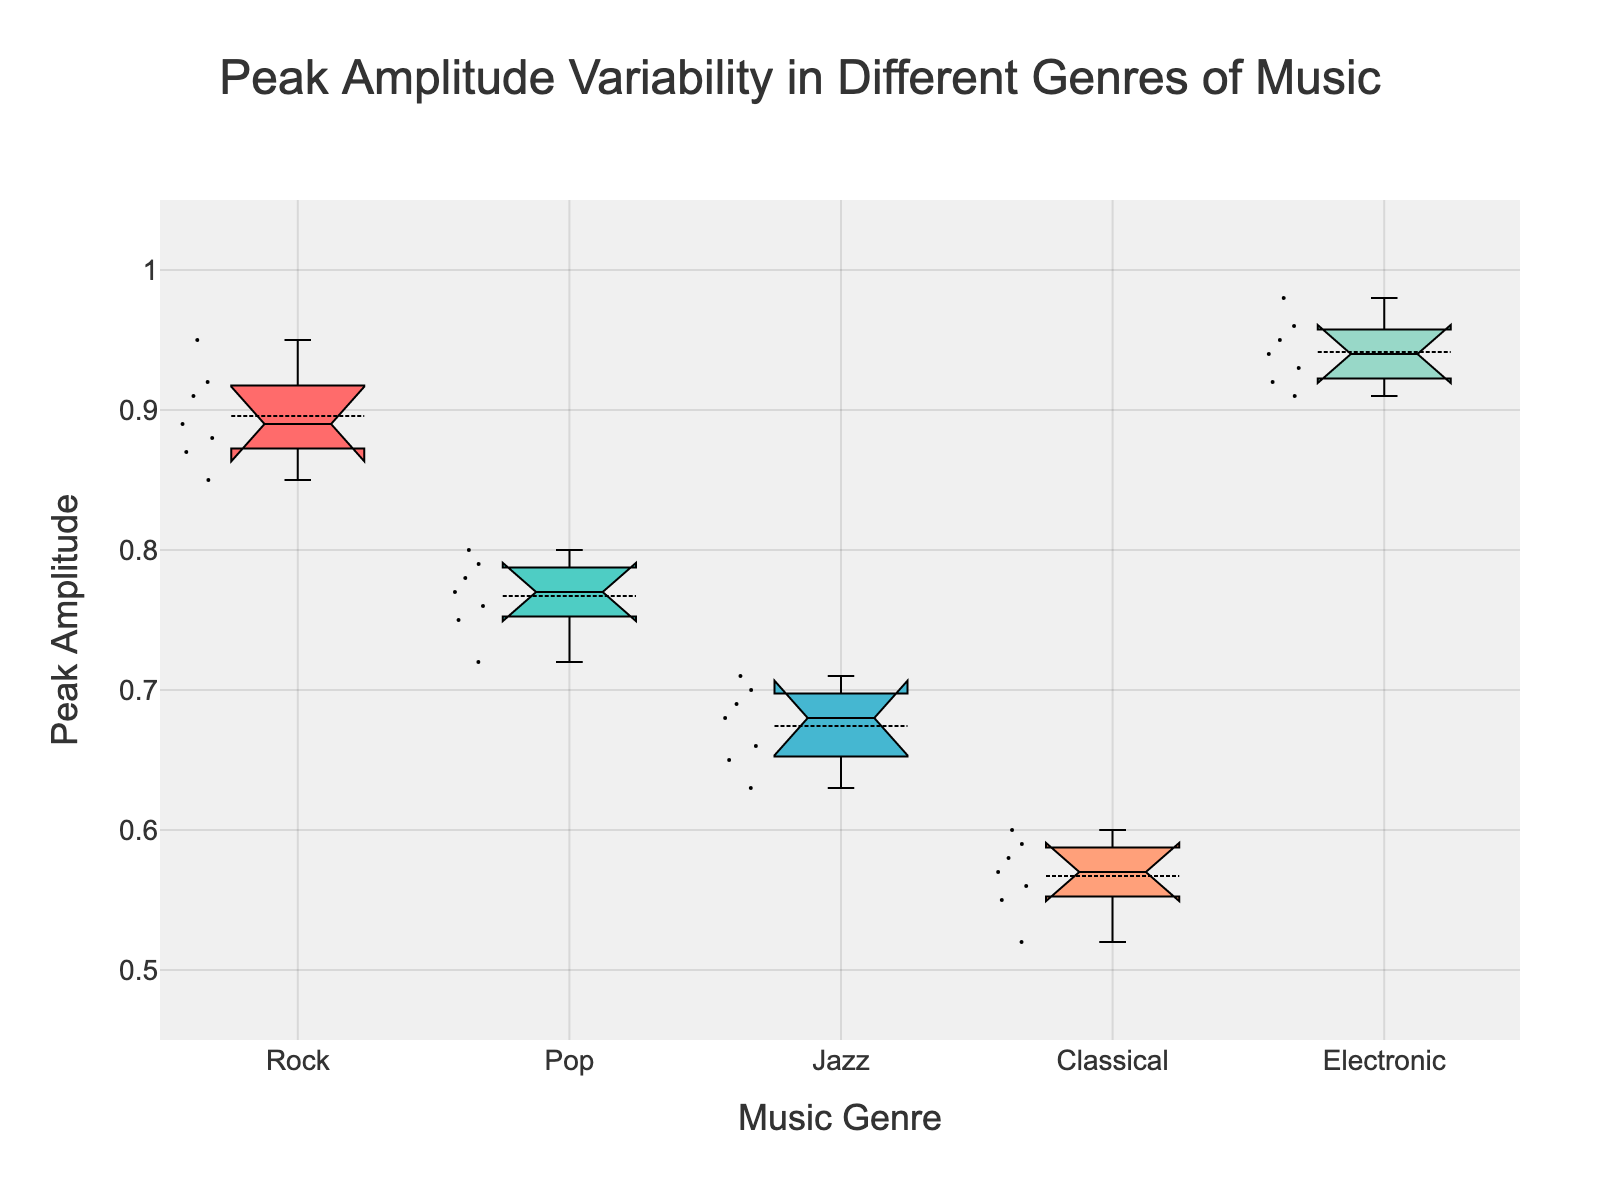What is the peak amplitude range for the Classical genre? The peak amplitude range for Classical can be determined by the lower and upper whiskers of the box plot for the Classical genre.
Answer: 0.52 to 0.60 Which genre has the highest median peak amplitude? The median peak amplitudes can be identified by the line inside each box. The genre with the highest median has the highest central line.
Answer: Electronic How does the median peak amplitude of Rock compare to Pop? By comparing the central lines of Rock and Pop boxes, we can see which one is higher.
Answer: Rock is higher than Pop Which genre shows the most variability in peak amplitude? Varied peak amplitude is shown by the length of the box and whiskers. The genre with the widest box and whiskers has the most variability.
Answer: Electronic Is the median peak amplitude of Jazz closer to Rock or Pop? By comparing the median lines of Jazz with those of Rock and Pop, we can determine which one is closer to Jazz.
Answer: Pop What is the interquartile range (IQR) for Pop? The IQR can be found by subtracting the lower quartile (bottom of the box) from the upper quartile (top of the box).
Answer: 0.08 Do any genres have overlapping notches? Notched box plots show overlap in medians if the notches intersect. Look for any intersecting notches among genres.
Answer: Yes Which genre has the smallest peak amplitude value? The smallest value can be found by looking at the lowest whisker in the box plot.
Answer: Classical Are there any outliers in the peak amplitude data? Outliers are individual points that appear outside the whiskers in the box plot.
Answer: No outliers 